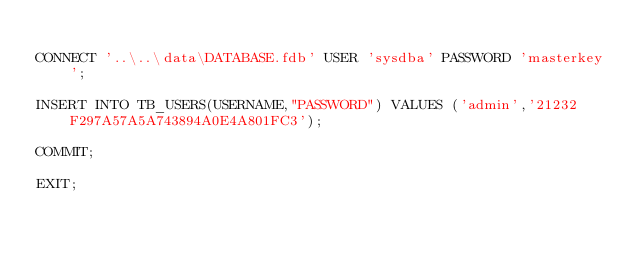<code> <loc_0><loc_0><loc_500><loc_500><_SQL_>
CONNECT '..\..\data\DATABASE.fdb' USER 'sysdba' PASSWORD 'masterkey';

INSERT INTO TB_USERS(USERNAME,"PASSWORD") VALUES ('admin','21232F297A57A5A743894A0E4A801FC3');

COMMIT;

EXIT;
</code> 